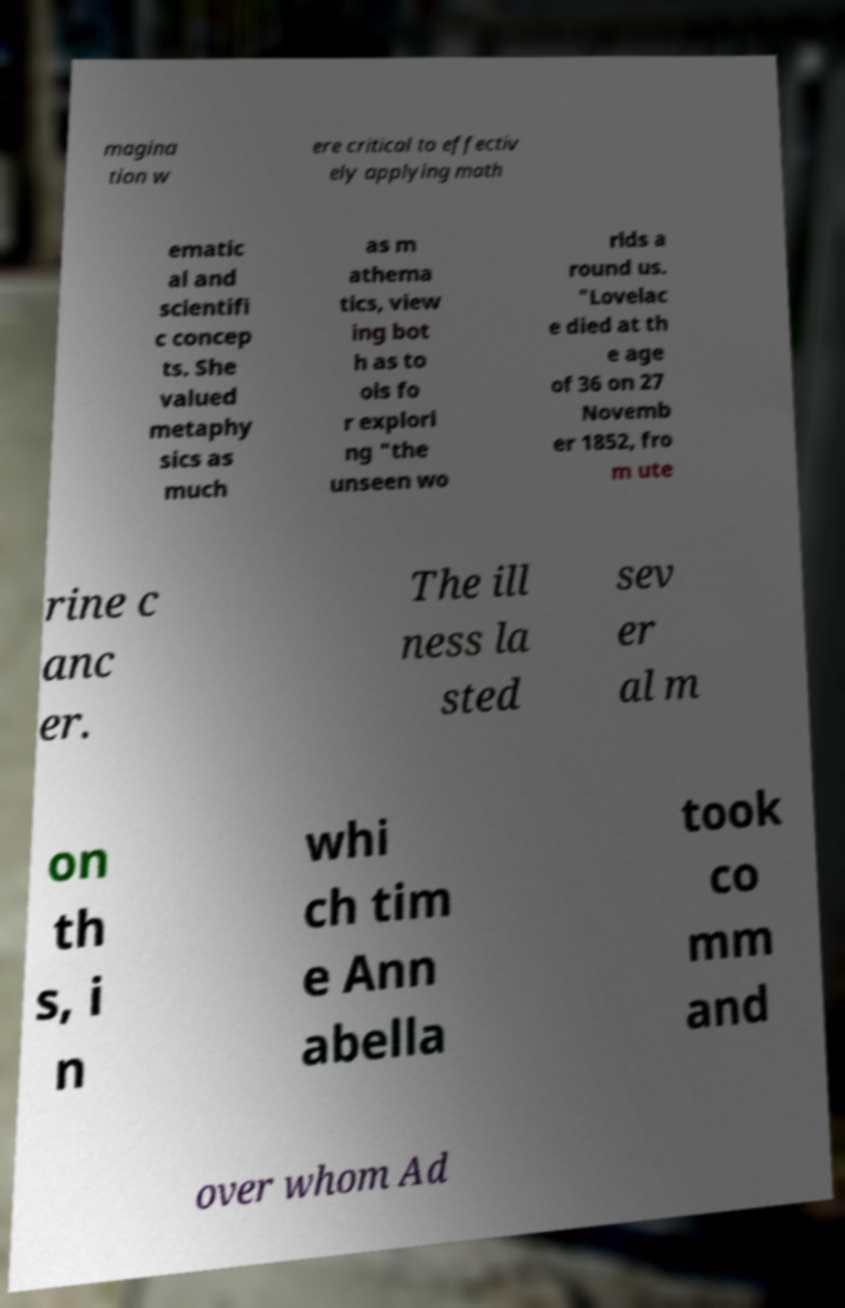I need the written content from this picture converted into text. Can you do that? magina tion w ere critical to effectiv ely applying math ematic al and scientifi c concep ts. She valued metaphy sics as much as m athema tics, view ing bot h as to ols fo r explori ng "the unseen wo rlds a round us. "Lovelac e died at th e age of 36 on 27 Novemb er 1852, fro m ute rine c anc er. The ill ness la sted sev er al m on th s, i n whi ch tim e Ann abella took co mm and over whom Ad 